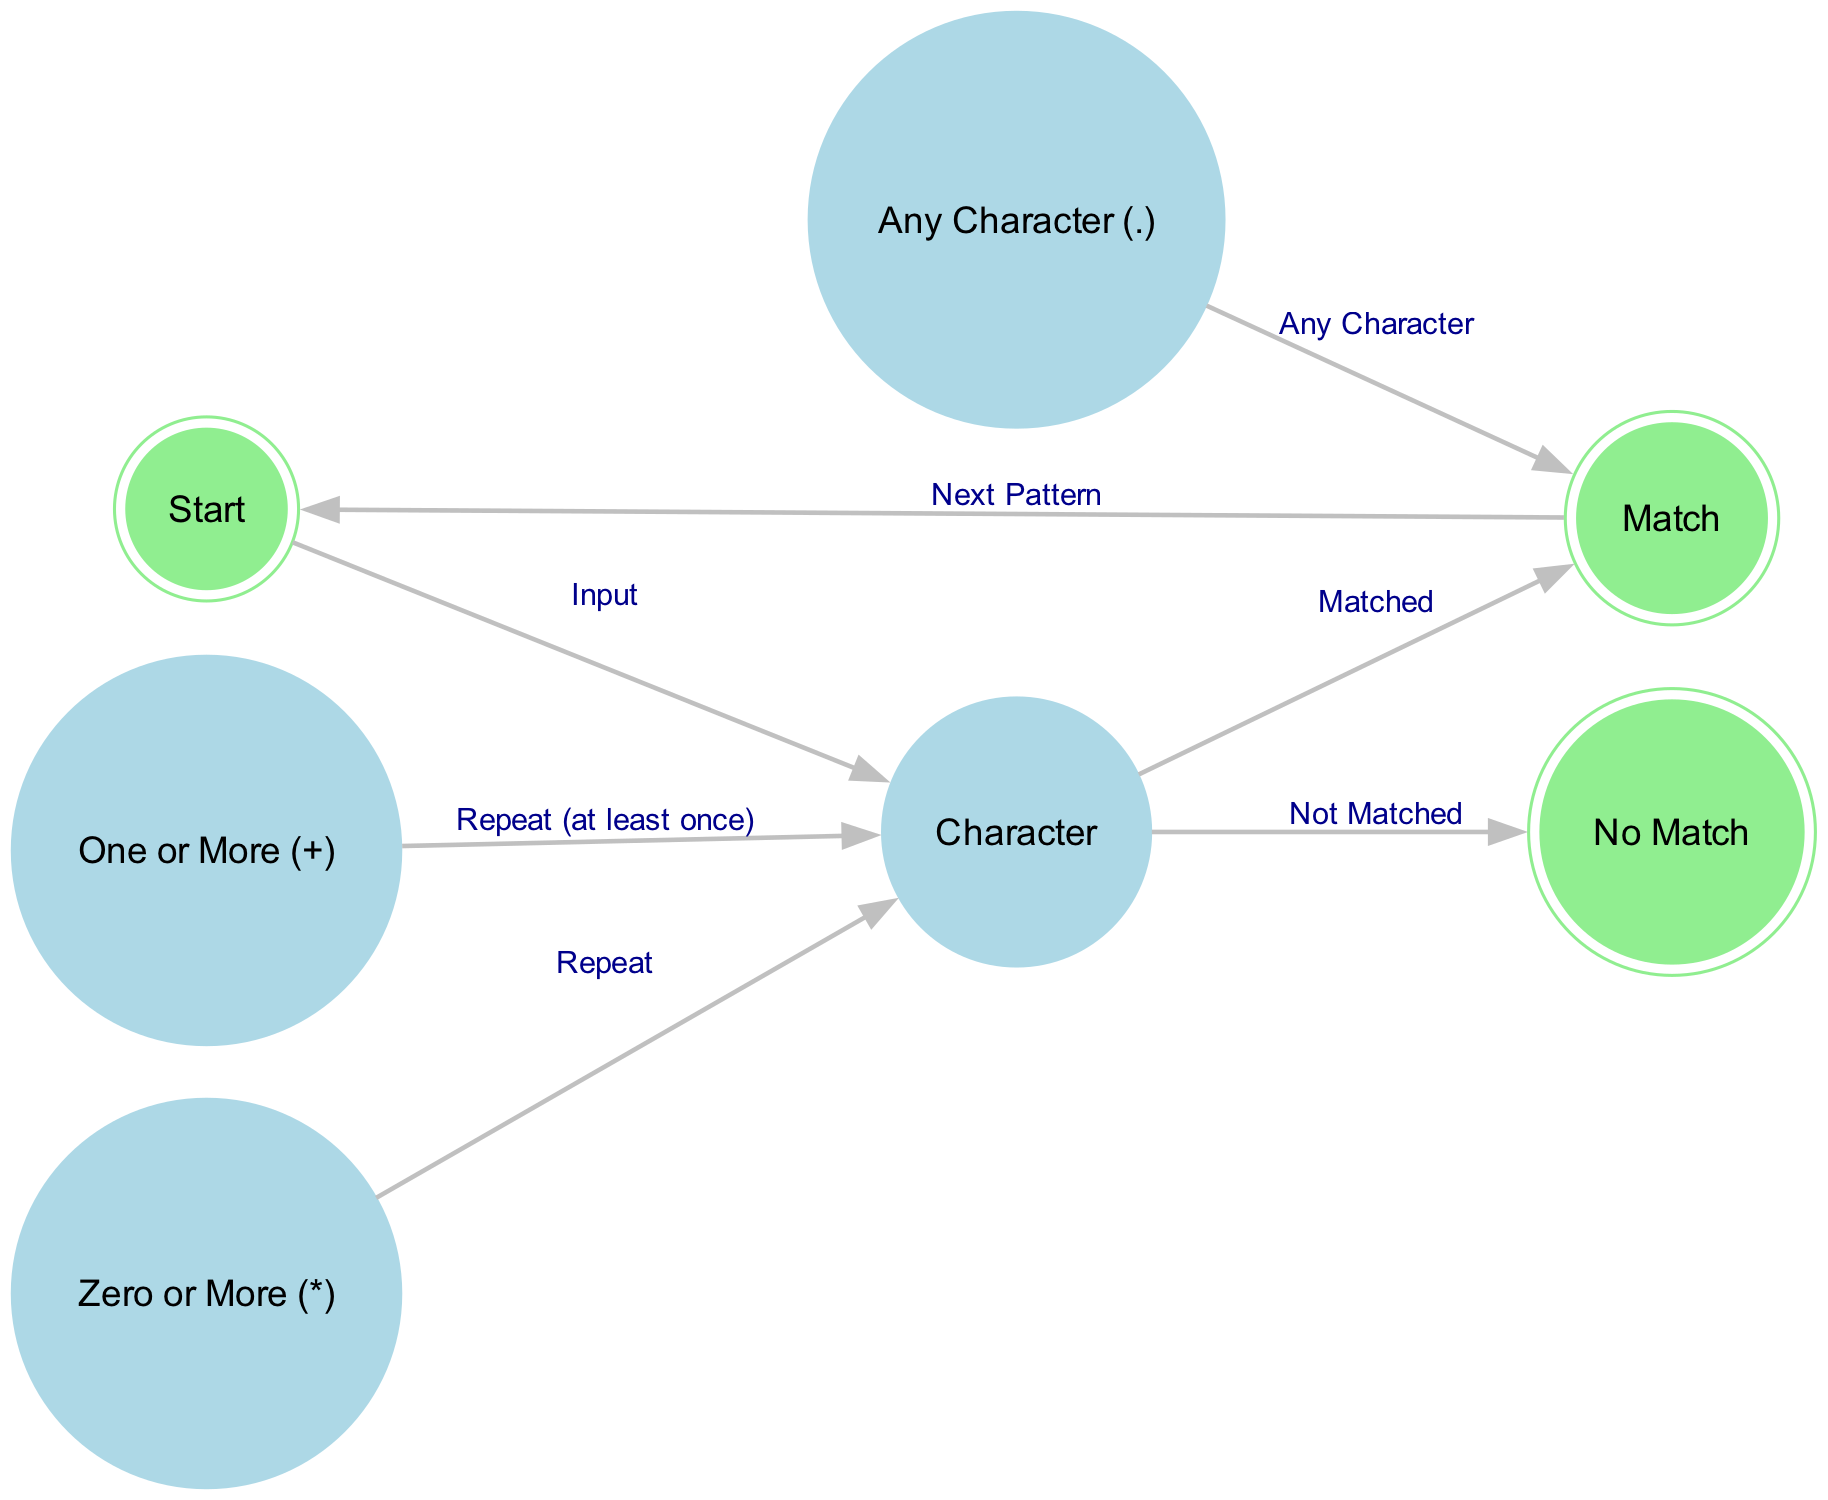What node represents the start of the state machine? The state machine begins at the node labeled "Start." This is indicated as the first node in the diagram's flow.
Answer: Start How many nodes are in the diagram? The diagram contains a total of seven nodes, including Start, Match, No Match, Character, Any Character (.), Zero or More (*), and One or More (+).
Answer: Seven What is the label for the edge from "Character" to "Match"? The edge from "Character" to "Match" is labeled "Matched," indicating that the input character successfully matched the expected pattern.
Answer: Matched Which node leads to "No Match"? The "Character" node leads to "No Match" when the input does not match the expected character. This flow is represented by the edge labeled "Not Matched."
Answer: Character What is the function of the "Zero or More (*)" node in the diagram? The "Zero or More (*)" node allows for repetition of the previous node's output, directing the flow back to the "Character" node, indicating that it can accept zero or more characters.
Answer: Repeat How does the state machine transition after a match is found? After matching is successful, the flow moves from "Match" back to "Start," indicating a transition for looking for the next pattern in the input sequence.
Answer: Next Pattern Which node allows for a match of any character? The "Any Character (.)" node allows for matching any character input. This is shown as an option that leads to the "Match" node.
Answer: Any Character What happens when the "One or More (+)" condition is satisfied? When the "One or More (+)" condition is satisfied, it loops back to the "Character" node, ensuring at least one character is present in the input for a successful match.
Answer: Repeat (at least once) What is the connection from "Zero or More (*)" to "Character"? The connection indicates that the zero or more condition enables a return to the "Character" node, allowing for more characters to be processed without a definite limit.
Answer: Repeat 